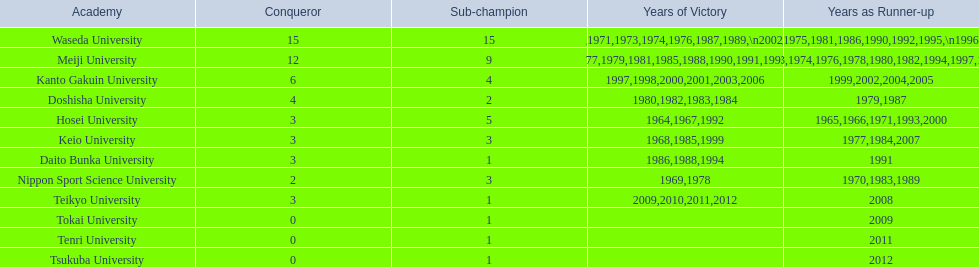Which university had 6 wins? Kanto Gakuin University. Which university had 12 wins? Meiji University. Would you mind parsing the complete table? {'header': ['Academy', 'Conqueror', 'Sub-champion', 'Years of Victory', 'Years as Runner-up'], 'rows': [['Waseda University', '15', '15', '1965,1966,1968,1970,1971,1973,1974,1976,1987,1989,\\n2002,2004,2005,2007,2008', '1964,1967,1969,1972,1975,1981,1986,1990,1992,1995,\\n1996,2001,2003,2006,2010'], ['Meiji University', '12', '9', '1972,1975,1977,1979,1981,1985,1988,1990,1991,1993,\\n1995,1996', '1973,1974,1976,1978,1980,1982,1994,1997,1998'], ['Kanto Gakuin University', '6', '4', '1997,1998,2000,2001,2003,2006', '1999,2002,2004,2005'], ['Doshisha University', '4', '2', '1980,1982,1983,1984', '1979,1987'], ['Hosei University', '3', '5', '1964,1967,1992', '1965,1966,1971,1993,2000'], ['Keio University', '3', '3', '1968,1985,1999', '1977,1984,2007'], ['Daito Bunka University', '3', '1', '1986,1988,1994', '1991'], ['Nippon Sport Science University', '2', '3', '1969,1978', '1970,1983,1989'], ['Teikyo University', '3', '1', '2009,2010,2011,2012', '2008'], ['Tokai University', '0', '1', '', '2009'], ['Tenri University', '0', '1', '', '2011'], ['Tsukuba University', '0', '1', '', '2012']]} Which university had more than 12 wins? Waseda University. 